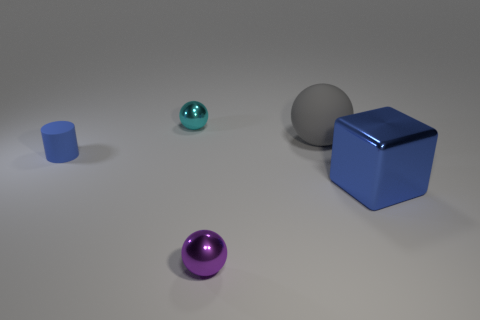Subtract all cyan metallic balls. How many balls are left? 2 Add 3 tiny brown rubber cylinders. How many objects exist? 8 Subtract 1 spheres. How many spheres are left? 2 Subtract all cylinders. How many objects are left? 4 Subtract all purple balls. How many balls are left? 2 Subtract 0 gray cylinders. How many objects are left? 5 Subtract all blue balls. Subtract all gray cubes. How many balls are left? 3 Subtract all tiny cyan metallic things. Subtract all cyan balls. How many objects are left? 3 Add 1 spheres. How many spheres are left? 4 Add 1 cyan cylinders. How many cyan cylinders exist? 1 